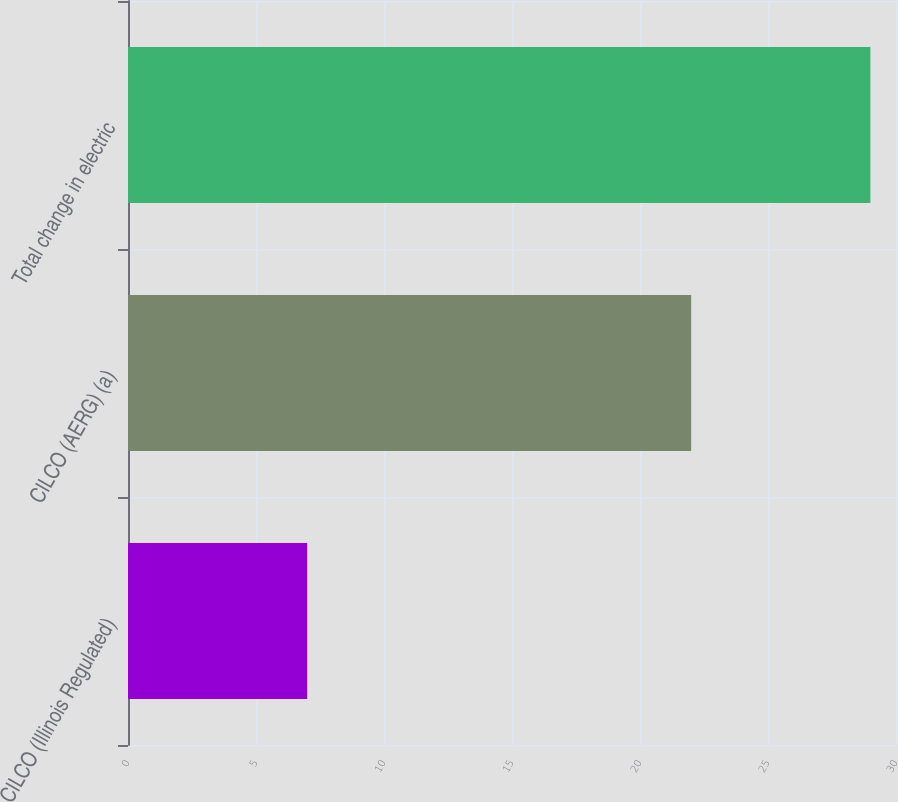Convert chart to OTSL. <chart><loc_0><loc_0><loc_500><loc_500><bar_chart><fcel>CILCO (Illinois Regulated)<fcel>CILCO (AERG) (a)<fcel>Total change in electric<nl><fcel>7<fcel>22<fcel>29<nl></chart> 